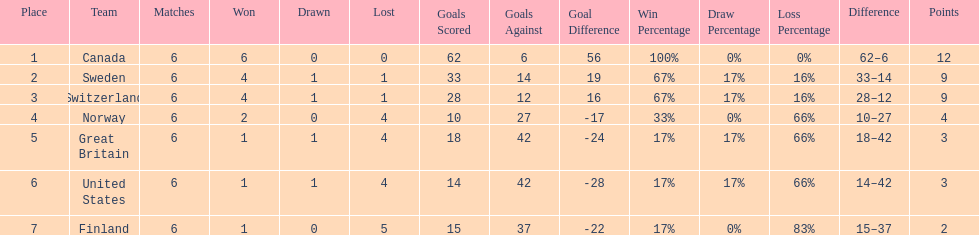How many teams won 6 matches? 1. 